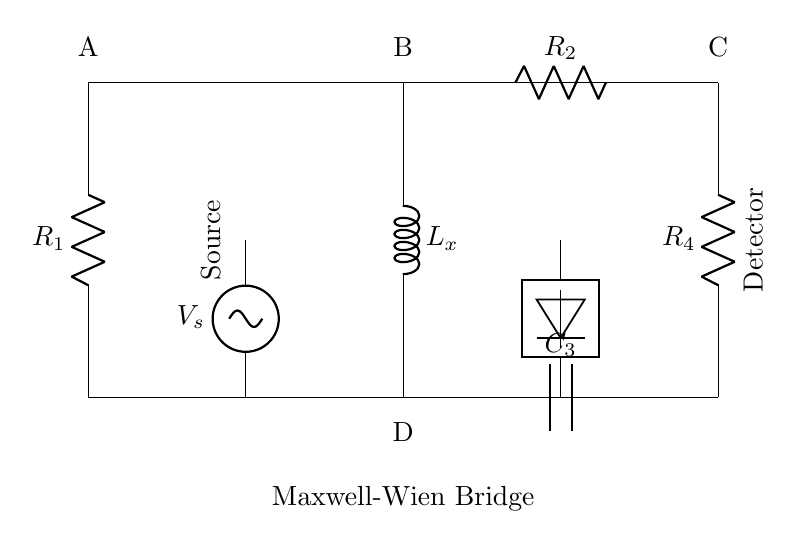What component is labeled L_x in this circuit? L_x represents the unknown inductance that is being measured by the Maxwell-Wien bridge.
Answer: unknown inductance What type of component is R_1? R_1 is a resistor, which is indicated by the label "R" with a value, typically measured in ohms.
Answer: resistor What is the function of the voltage source in this circuit? The voltage source provides the alternating current needed for the operation of the bridge, powering the circuit to achieve balance.
Answer: power supply How many resistors are present in the circuit? There are three resistors in the circuit: R_1, R_2, and R_4.
Answer: three What does the detector measure in this bridge circuit? The detector measures the balance of the bridge, indicating when the circuit is perfectly balanced between the known and unknown values.
Answer: balance If R_2 is twice the value of R_1, what can be inferred about L_x? In a balanced state, if R_2 is twice R_1, L_x must effectively relate to these resistances and the capacitance value, allowing for calculation based on known impedance principles.
Answer: specific inductance value needed What is the role of C_3 in this bridge arrangement? C_3 is a capacitor that helps to achieve the phase difference necessary for the bridge's balance condition, allowing the calculation of the unknown inductance under AC conditions.
Answer: phase adjustment 